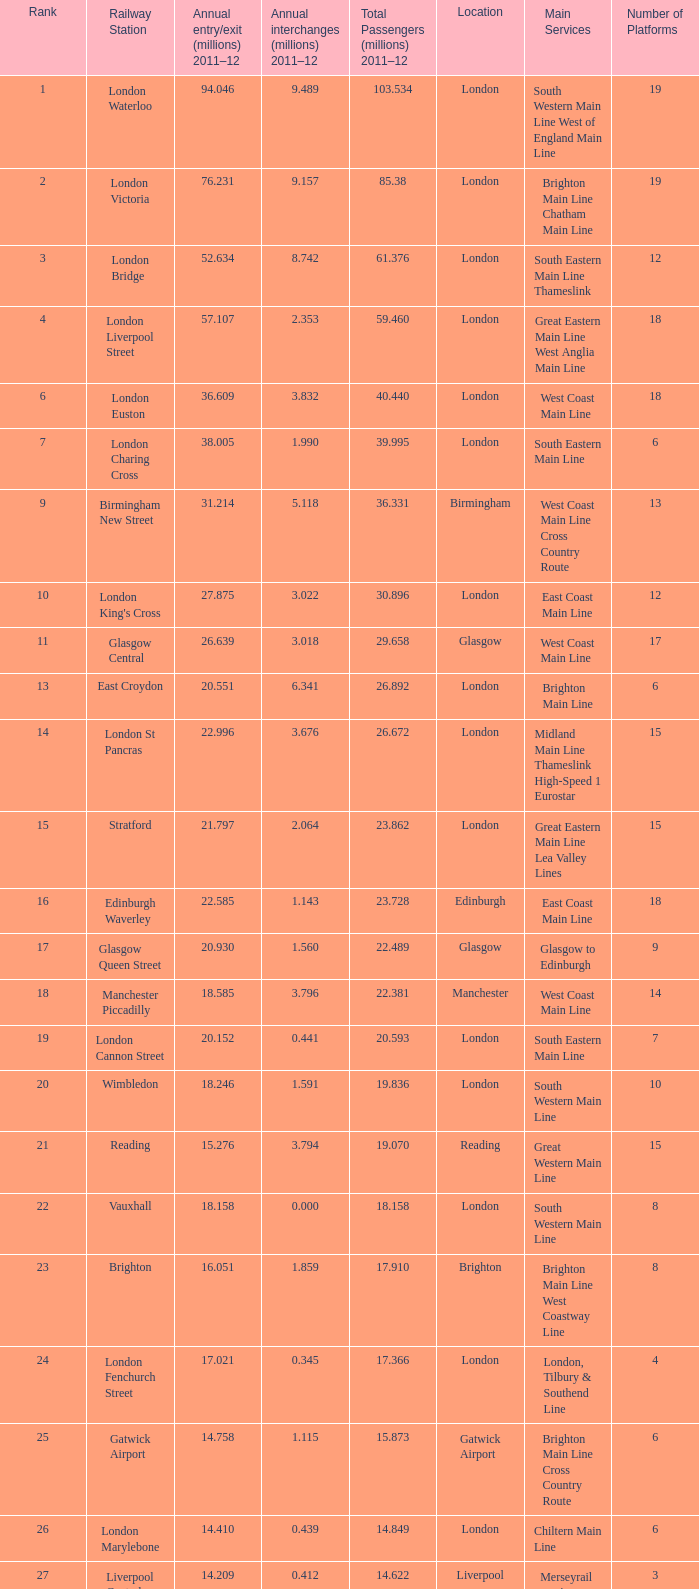534 million passengers in 2011-12? London. 